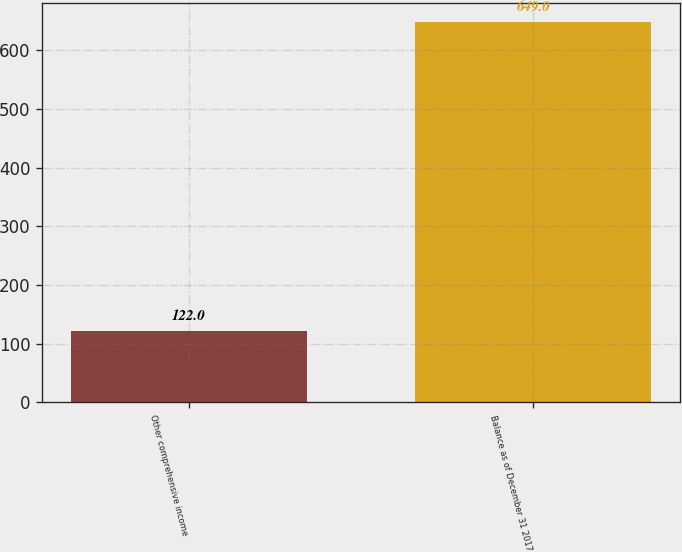<chart> <loc_0><loc_0><loc_500><loc_500><bar_chart><fcel>Other comprehensive income<fcel>Balance as of December 31 2017<nl><fcel>122<fcel>649<nl></chart> 